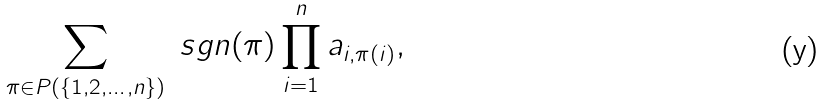Convert formula to latex. <formula><loc_0><loc_0><loc_500><loc_500>\sum _ { \pi \in P ( \{ 1 , 2 , \dots , n \} ) } \ s g n ( \pi ) \prod _ { i = 1 } ^ { n } a _ { i , \pi ( i ) } ,</formula> 